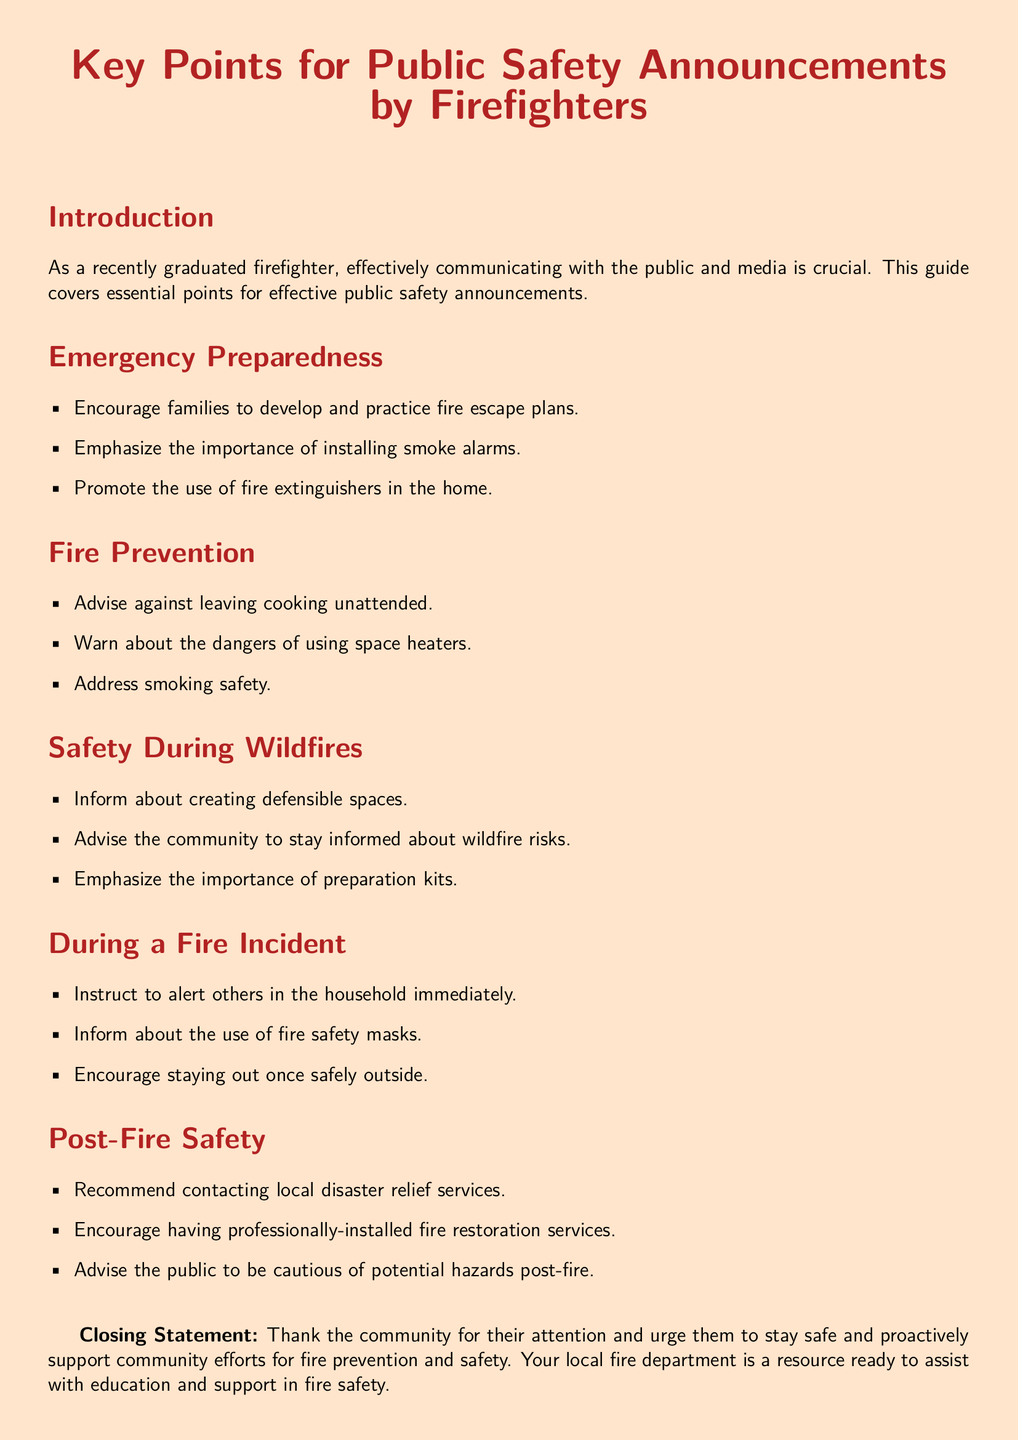what are the key points for public safety announcements? The key points for public safety announcements are listed in the document as emergency preparedness, fire prevention, safety during wildfires, during a fire incident, and post-fire safety.
Answer: emergency preparedness, fire prevention, safety during wildfires, during a fire incident, post-fire safety who should develop fire escape plans? The document encourages families to develop and practice fire escape plans, indicating that the advice is targeted towards families.
Answer: families what should you install to enhance safety? The document emphasizes the importance of installing smoke alarms.
Answer: smoke alarms what action should you take when a fire incident occurs? The document instructs to alert others in the household immediately during a fire incident.
Answer: alert others which services should be contacted post-fire? The document recommends contacting local disaster relief services after a fire.
Answer: local disaster relief services what is one important item to have for wildfire preparedness? The document highlights the importance of preparation kits for wildfire preparedness.
Answer: preparation kits name one fire prevention method mentioned in the document. The document advises against leaving cooking unattended as a fire prevention method.
Answer: leaving cooking unattended why is staying informed about wildfire risks important? The document advises the community to stay informed about wildfire risks, indicating that awareness is key for safety.
Answer: awareness what should a firefighter promote related to fire extinguishers? The document promotes the use of fire extinguishers in the home as part of emergency preparedness.
Answer: use of fire extinguishers 